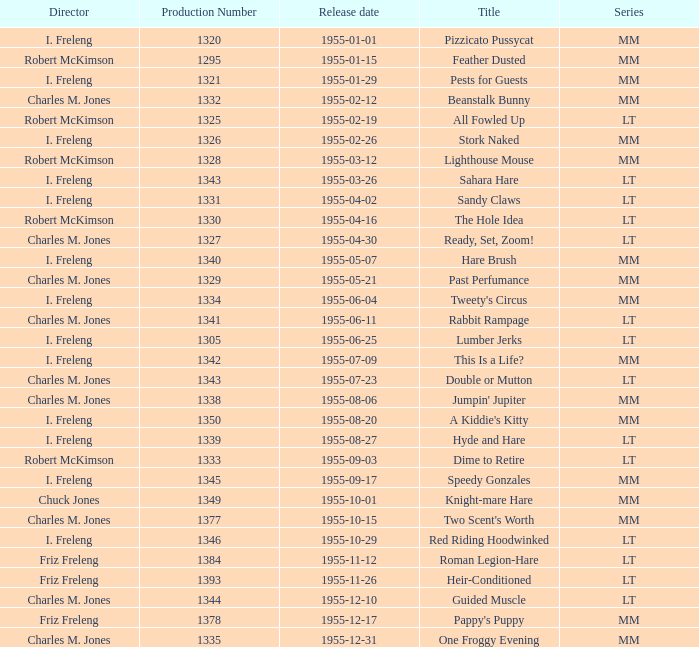What is the release date of production number 1327? 1955-04-30. 